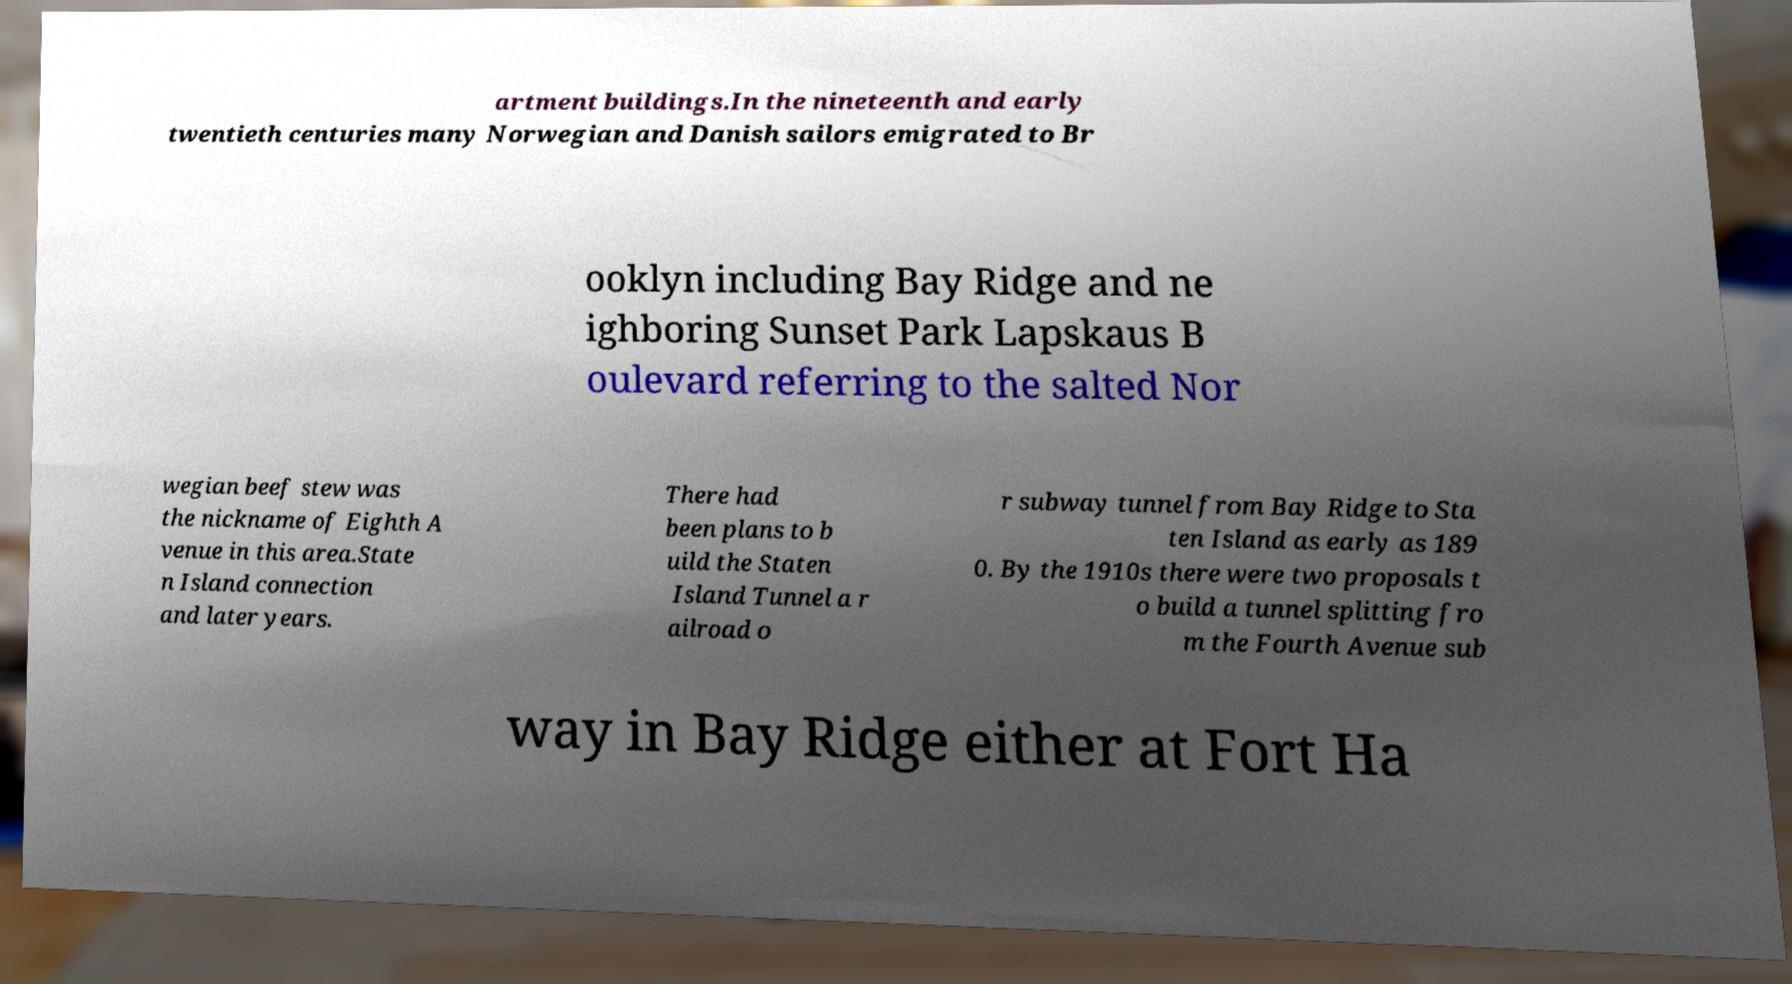There's text embedded in this image that I need extracted. Can you transcribe it verbatim? artment buildings.In the nineteenth and early twentieth centuries many Norwegian and Danish sailors emigrated to Br ooklyn including Bay Ridge and ne ighboring Sunset Park Lapskaus B oulevard referring to the salted Nor wegian beef stew was the nickname of Eighth A venue in this area.State n Island connection and later years. There had been plans to b uild the Staten Island Tunnel a r ailroad o r subway tunnel from Bay Ridge to Sta ten Island as early as 189 0. By the 1910s there were two proposals t o build a tunnel splitting fro m the Fourth Avenue sub way in Bay Ridge either at Fort Ha 